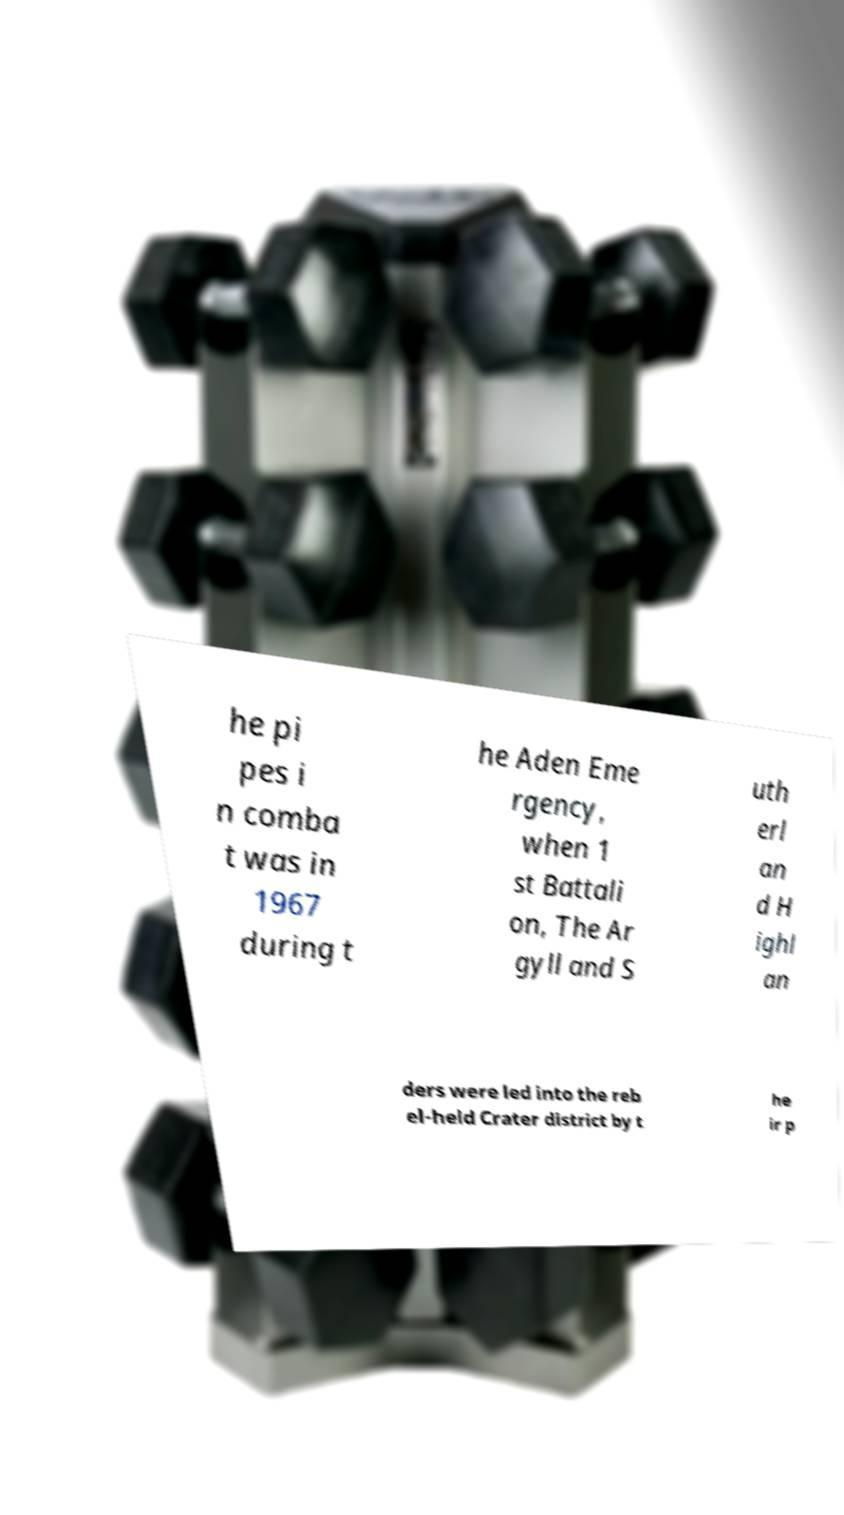Can you accurately transcribe the text from the provided image for me? he pi pes i n comba t was in 1967 during t he Aden Eme rgency, when 1 st Battali on, The Ar gyll and S uth erl an d H ighl an ders were led into the reb el-held Crater district by t he ir p 